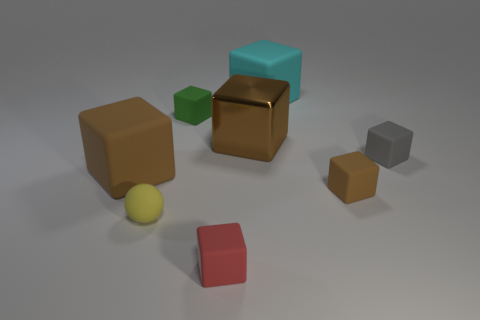How many tiny red matte cubes are behind the brown metal block?
Offer a terse response. 0. There is a thing that is to the right of the large cyan matte block and left of the small gray rubber block; what is its size?
Your answer should be very brief. Small. Is there a large red shiny ball?
Make the answer very short. No. What number of other objects are there of the same size as the metal thing?
Give a very brief answer. 2. Do the big rubber object that is in front of the cyan matte cube and the small cube that is in front of the small yellow ball have the same color?
Your answer should be very brief. No. There is a brown metallic thing that is the same shape as the gray thing; what size is it?
Keep it short and to the point. Large. Do the small cube that is in front of the tiny brown matte cube and the object behind the green rubber cube have the same material?
Offer a terse response. Yes. How many rubber objects are big cyan cubes or tiny things?
Offer a very short reply. 6. There is a object that is to the right of the tiny brown block to the right of the tiny matte cube that is in front of the small rubber sphere; what is its material?
Your answer should be very brief. Rubber. There is a brown thing that is behind the gray object; does it have the same shape as the brown thing that is left of the tiny red matte thing?
Ensure brevity in your answer.  Yes. 